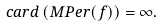Convert formula to latex. <formula><loc_0><loc_0><loc_500><loc_500>c a r d \left ( M P e r ( f ) \right ) = \infty .</formula> 